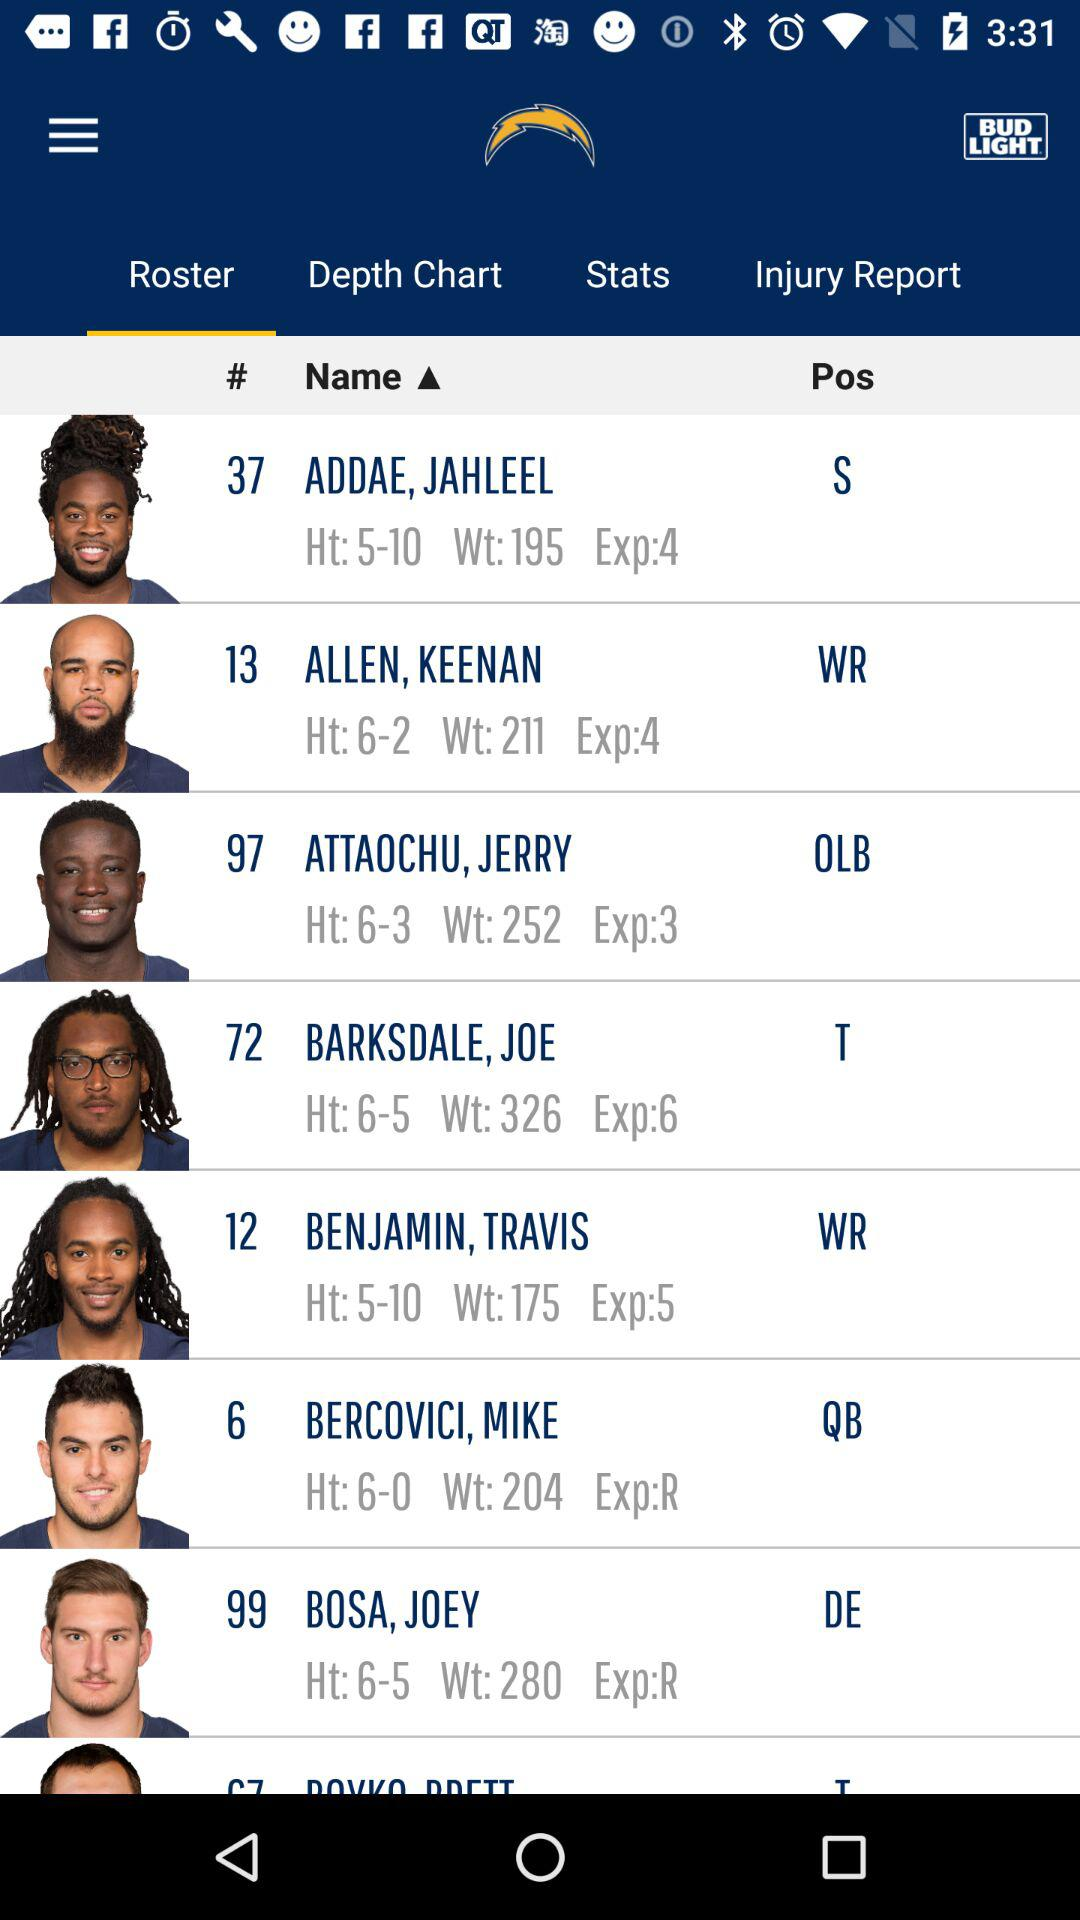What is the exp of Joe Barksdale? The exp of Joe Barksdale is 6. 